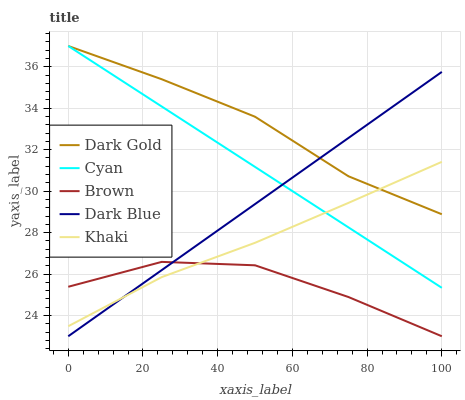Does Brown have the minimum area under the curve?
Answer yes or no. Yes. Does Dark Gold have the maximum area under the curve?
Answer yes or no. Yes. Does Dark Blue have the minimum area under the curve?
Answer yes or no. No. Does Dark Blue have the maximum area under the curve?
Answer yes or no. No. Is Cyan the smoothest?
Answer yes or no. Yes. Is Brown the roughest?
Answer yes or no. Yes. Is Dark Blue the smoothest?
Answer yes or no. No. Is Dark Blue the roughest?
Answer yes or no. No. Does Dark Blue have the lowest value?
Answer yes or no. Yes. Does Khaki have the lowest value?
Answer yes or no. No. Does Dark Gold have the highest value?
Answer yes or no. Yes. Does Dark Blue have the highest value?
Answer yes or no. No. Is Brown less than Cyan?
Answer yes or no. Yes. Is Cyan greater than Brown?
Answer yes or no. Yes. Does Brown intersect Dark Blue?
Answer yes or no. Yes. Is Brown less than Dark Blue?
Answer yes or no. No. Is Brown greater than Dark Blue?
Answer yes or no. No. Does Brown intersect Cyan?
Answer yes or no. No. 